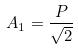<formula> <loc_0><loc_0><loc_500><loc_500>A _ { 1 } = \frac { P } { \sqrt { 2 } }</formula> 